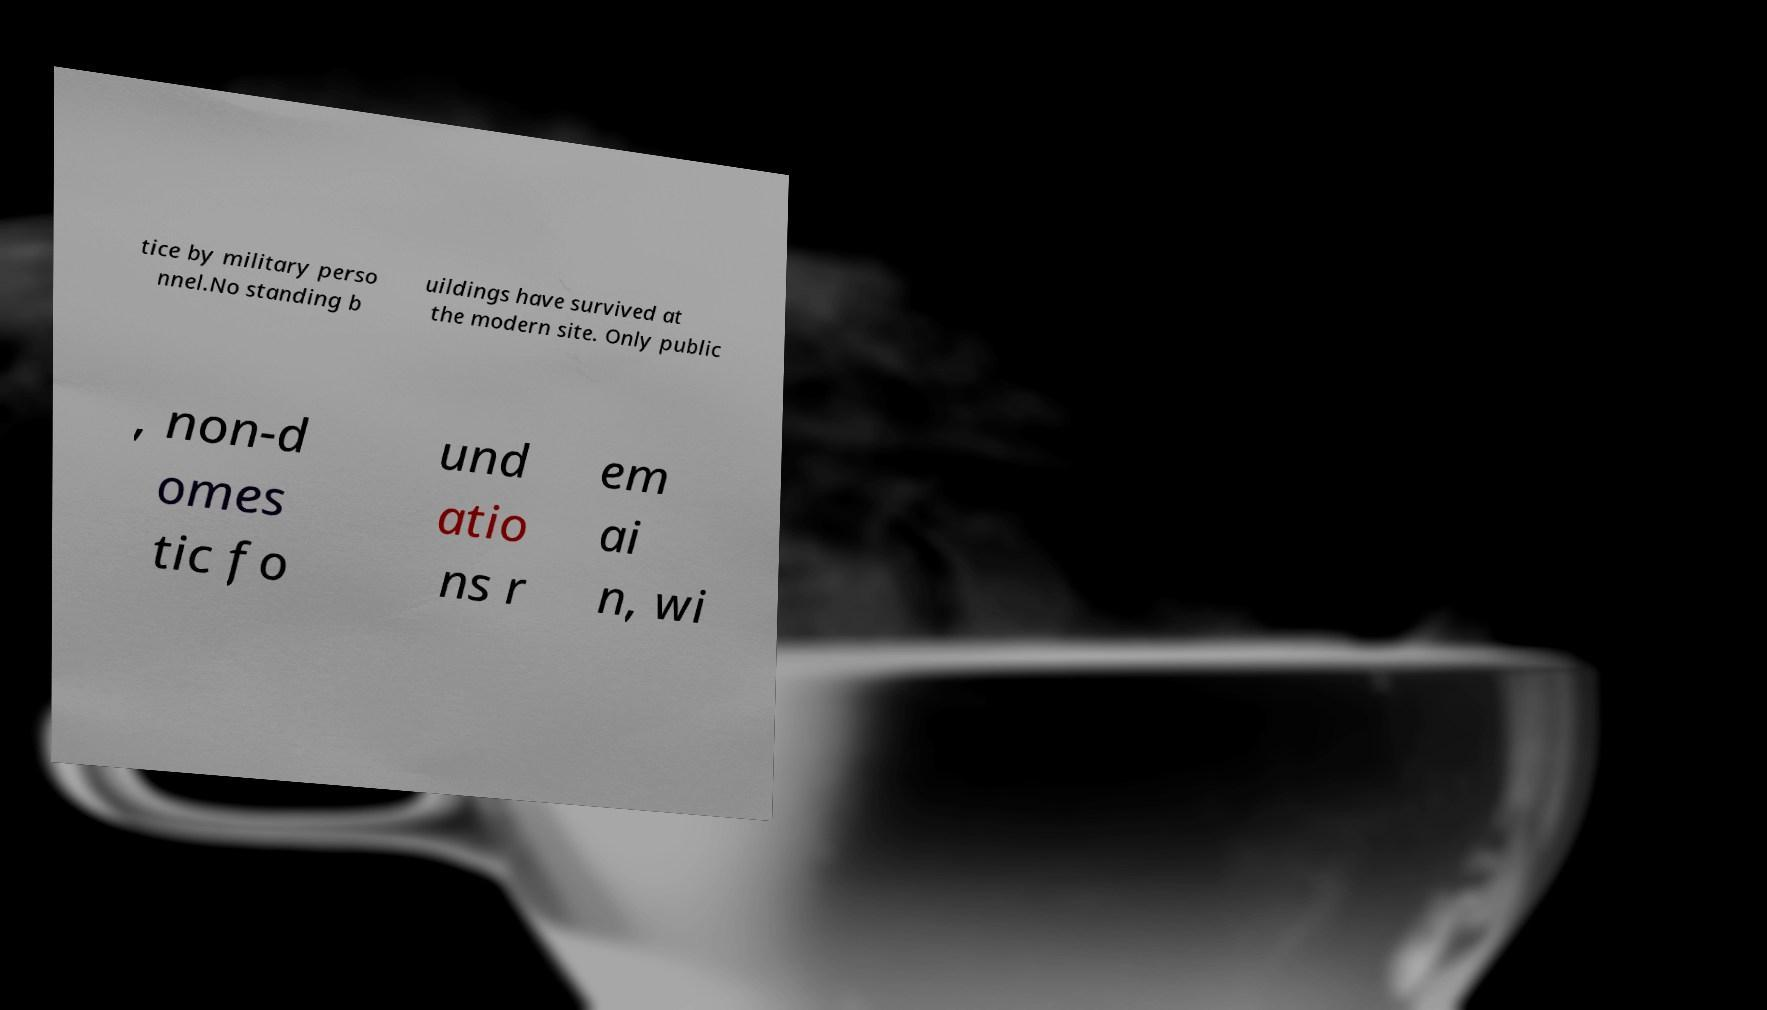What messages or text are displayed in this image? I need them in a readable, typed format. tice by military perso nnel.No standing b uildings have survived at the modern site. Only public , non-d omes tic fo und atio ns r em ai n, wi 